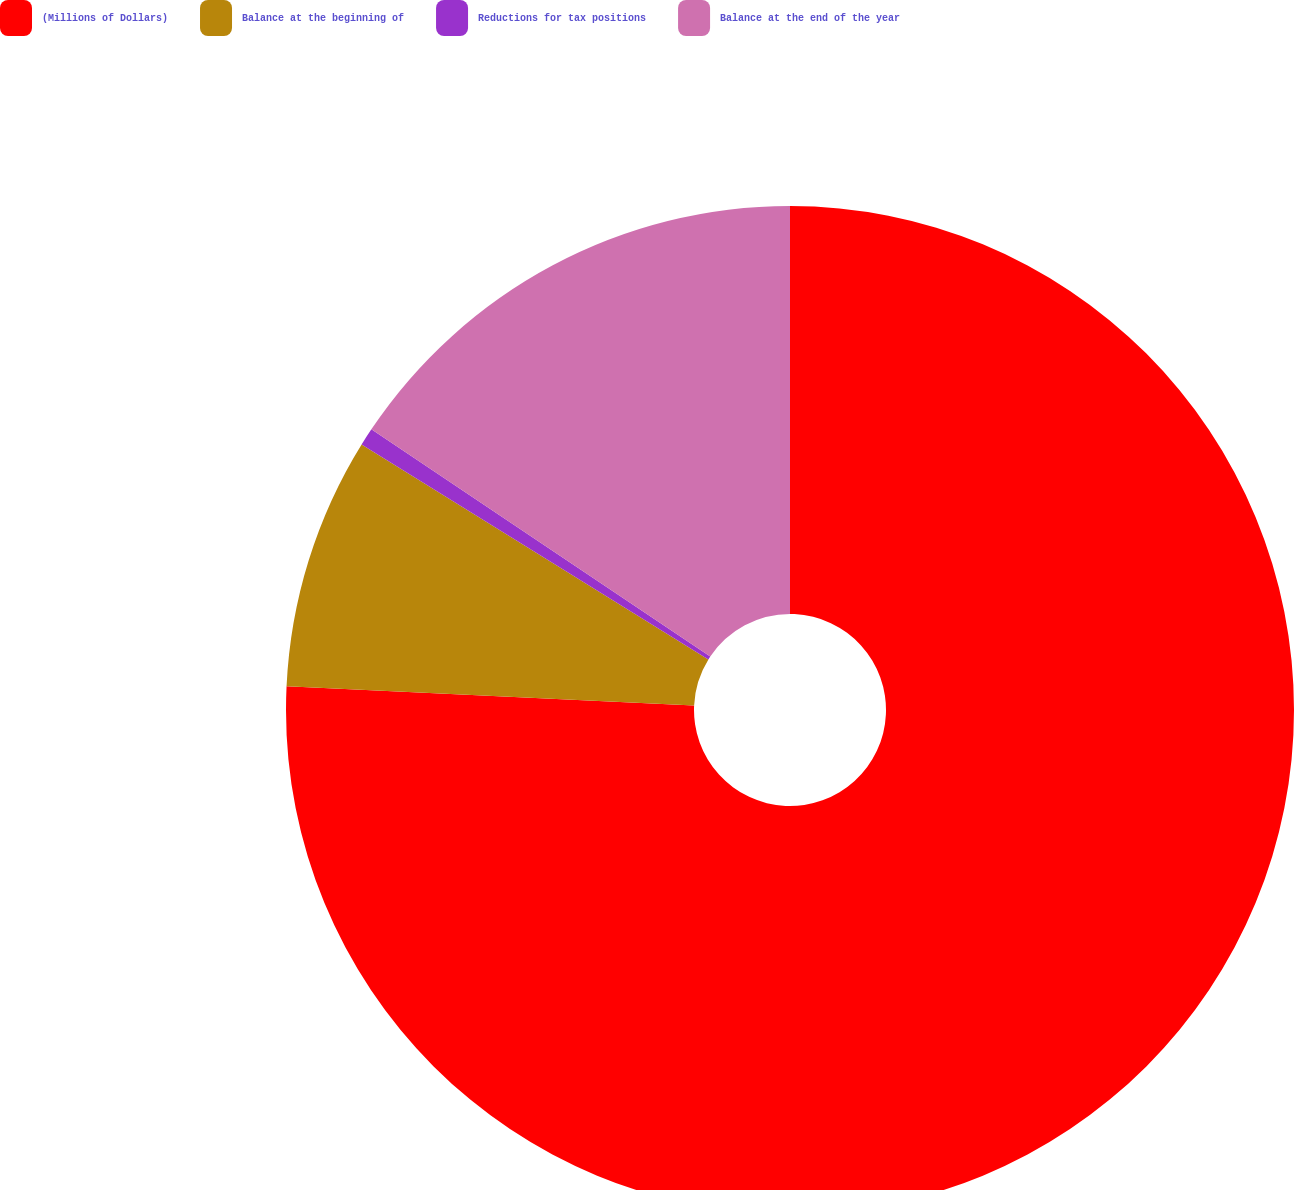Convert chart to OTSL. <chart><loc_0><loc_0><loc_500><loc_500><pie_chart><fcel>(Millions of Dollars)<fcel>Balance at the beginning of<fcel>Reductions for tax positions<fcel>Balance at the end of the year<nl><fcel>75.75%<fcel>8.08%<fcel>0.57%<fcel>15.6%<nl></chart> 